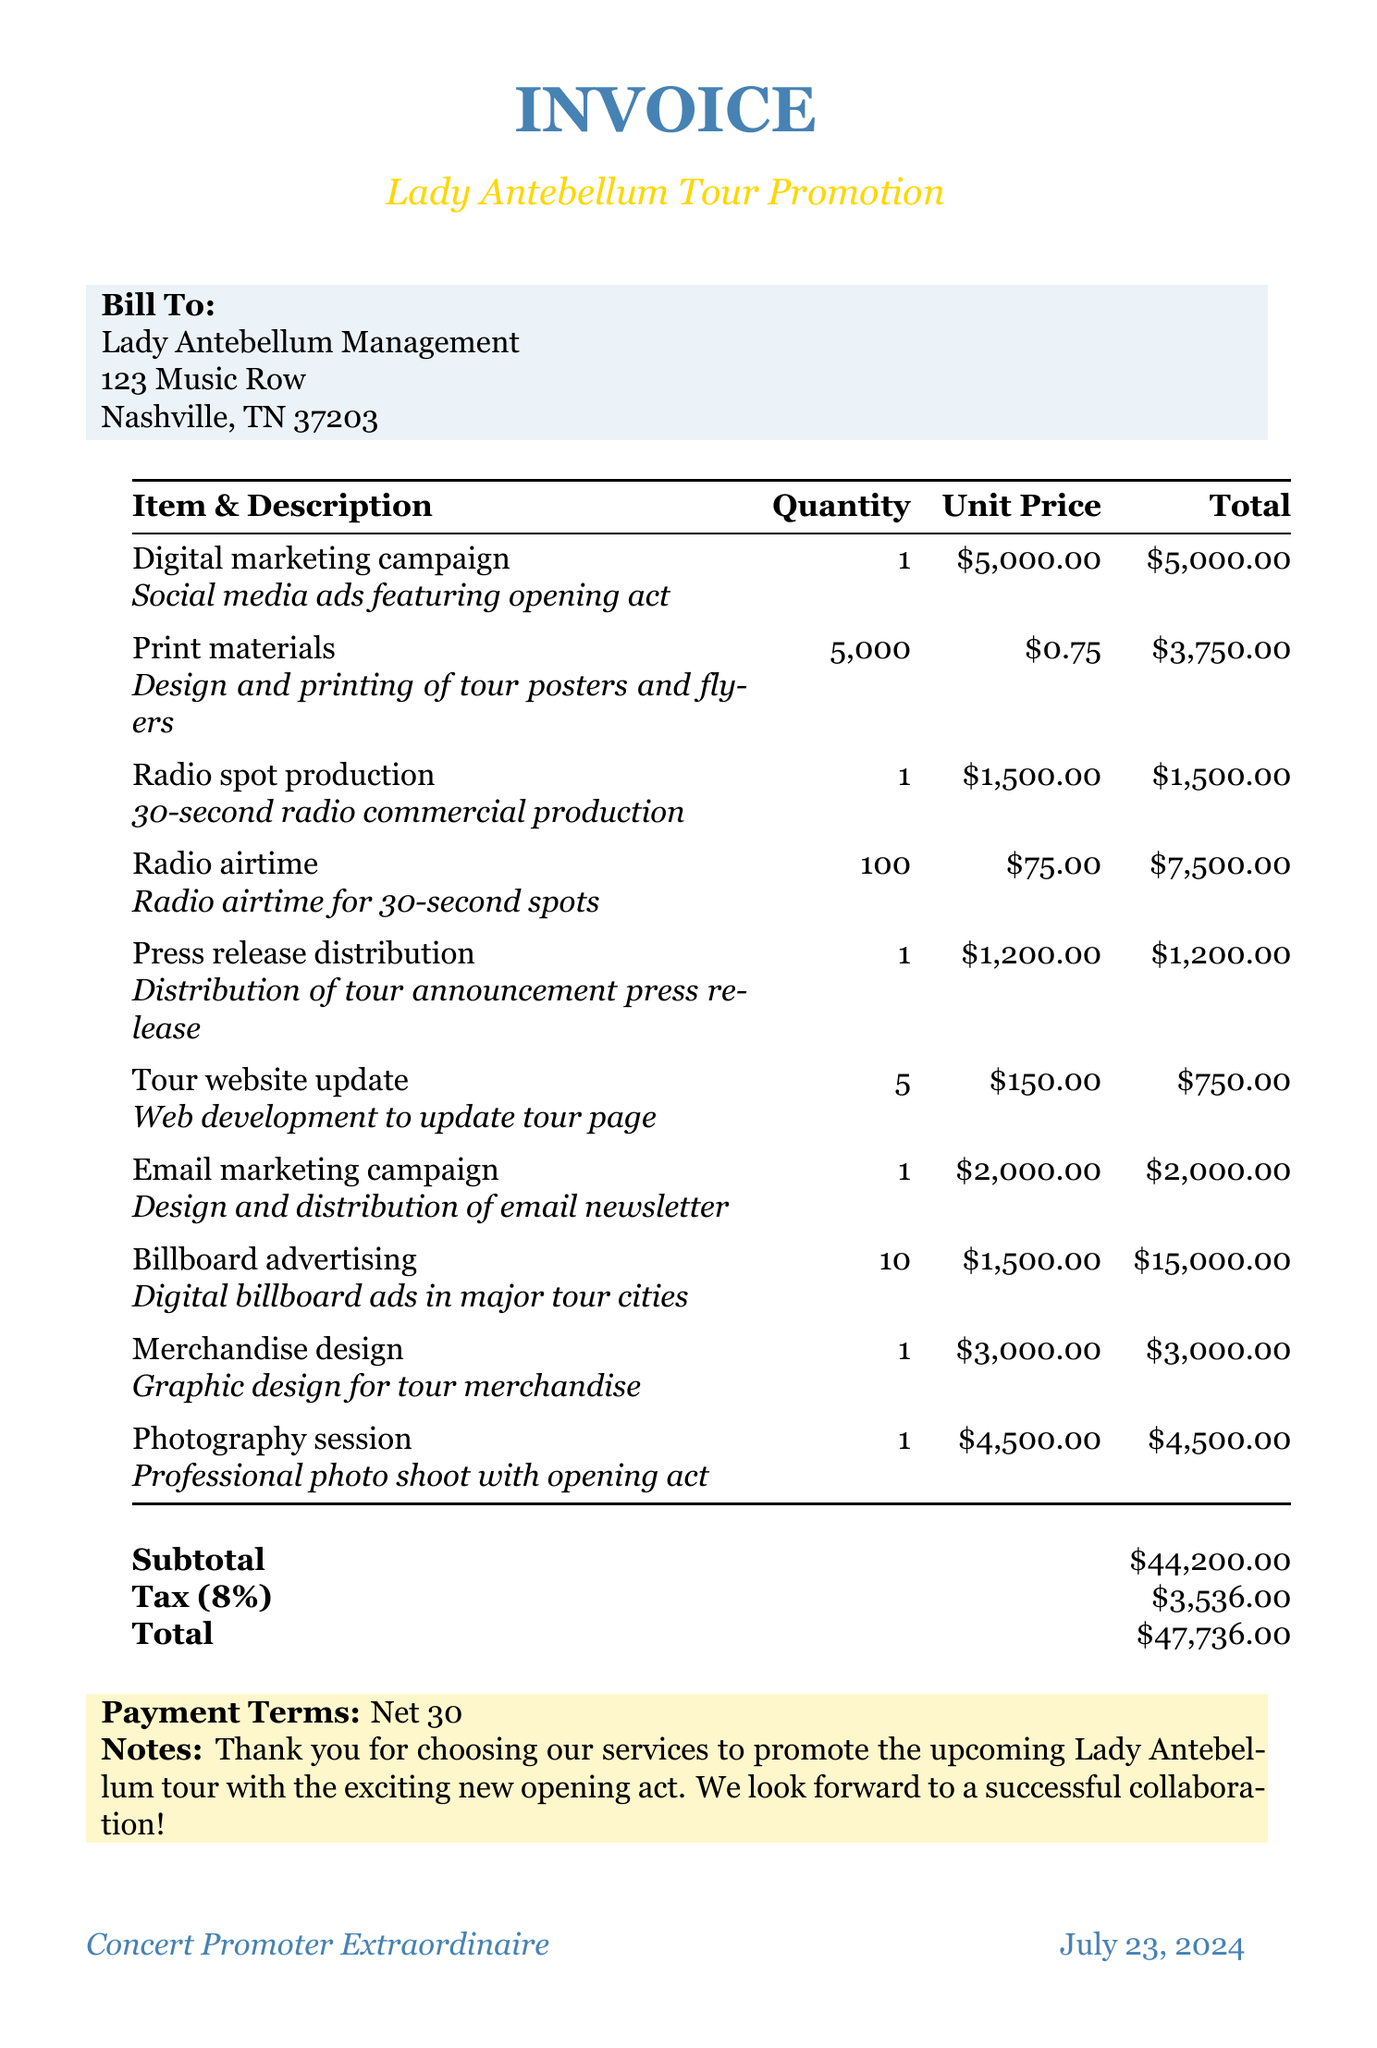What is the total cost for the digital marketing campaign? The total cost for the digital marketing campaign is listed in the invoice, which is $5000.
Answer: $5000 How much does printing the materials cost? The cost for printing materials is derived from the quantity and unit price provided, which results in a total of $3750.
Answer: $3750 What is the tax rate applied to the subtotal? The tax rate is specified in the document as 8%, applied to the subtotal of the invoice.
Answer: 8% What is the subtotal amount before tax? The subtotal amount is directly stated in the document, prior to tax being added, which is $44200.
Answer: $44200 How many digital billboard ads are included in the invoice? The document indicates that 10 digital billboard ads are included in the promotion costs for the tour.
Answer: 10 What is the payment term specified in the document? The payment term is noted in the document as "Net 30," indicating the time frame for payment.
Answer: Net 30 What is the total amount due including tax? The total amount due is calculated as the subtotal plus tax, which totals to $47736.
Answer: $47736 How many press releases are being distributed? The invoice states that the distribution of 1 tour announcement press release is included in the promotional costs.
Answer: 1 What service is provided for the photography session? The invoice details that a professional photo shoot of Lady Antebellum with the opening act is included in the services offered.
Answer: Professional photo shoot 